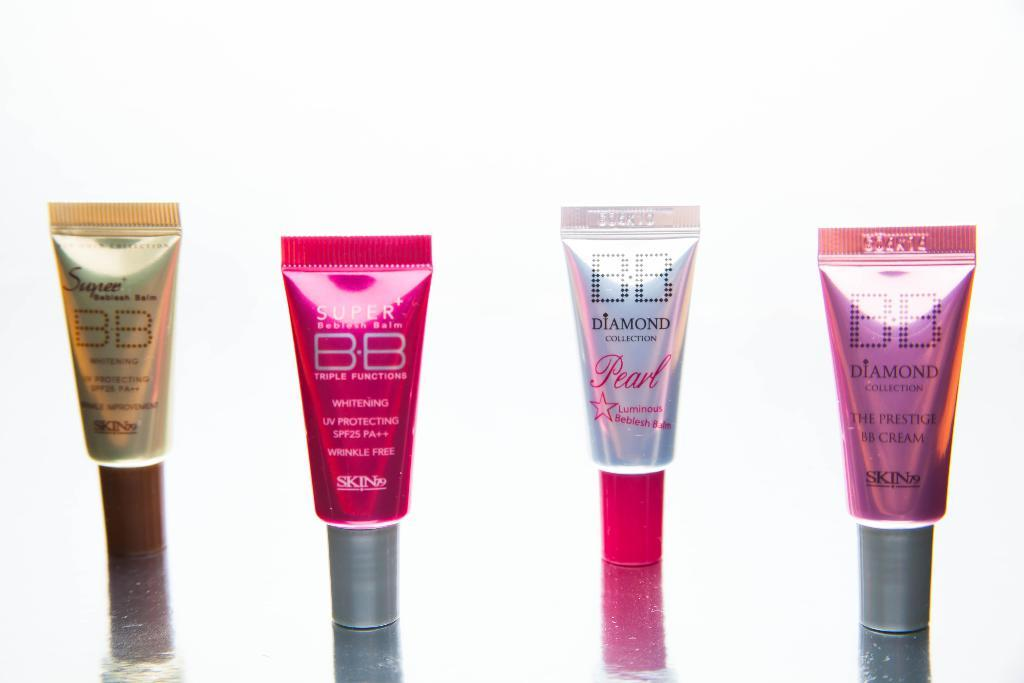<image>
Describe the image concisely. some makeup items with the letters BB at the top of them 